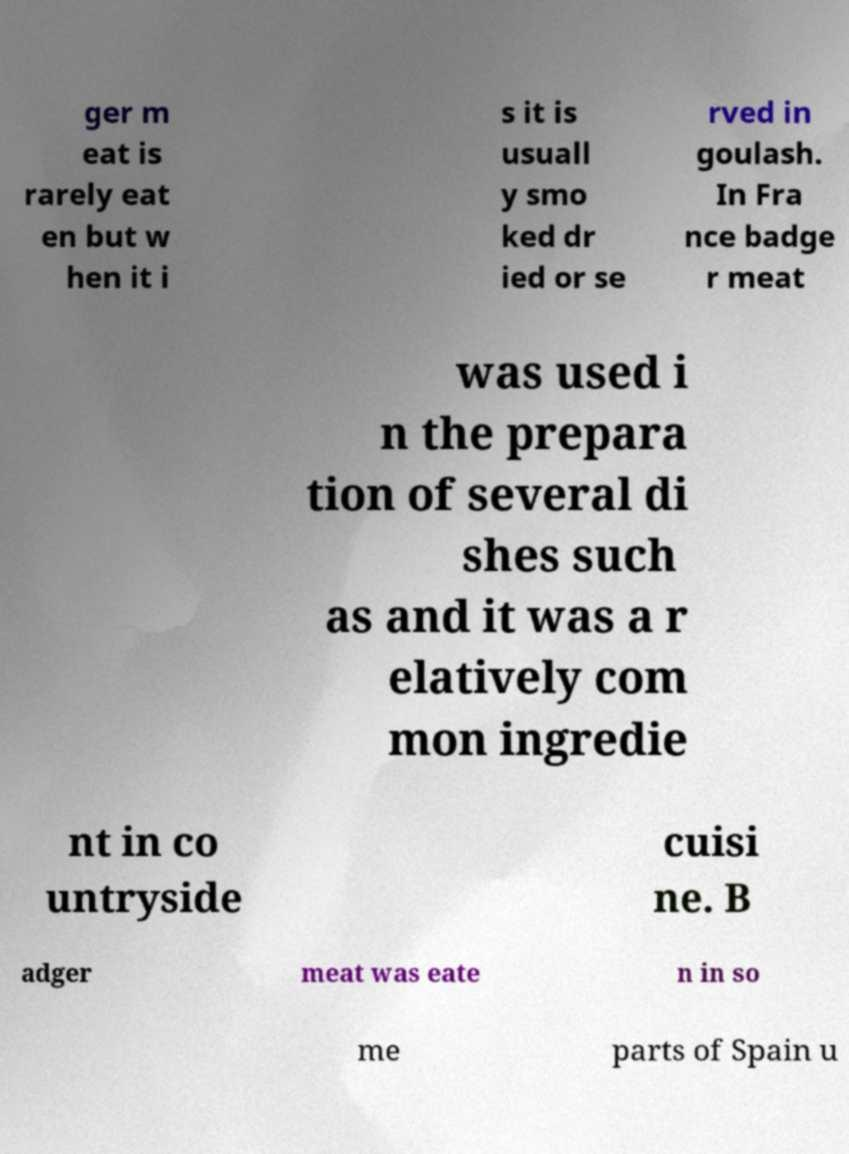Can you accurately transcribe the text from the provided image for me? ger m eat is rarely eat en but w hen it i s it is usuall y smo ked dr ied or se rved in goulash. In Fra nce badge r meat was used i n the prepara tion of several di shes such as and it was a r elatively com mon ingredie nt in co untryside cuisi ne. B adger meat was eate n in so me parts of Spain u 